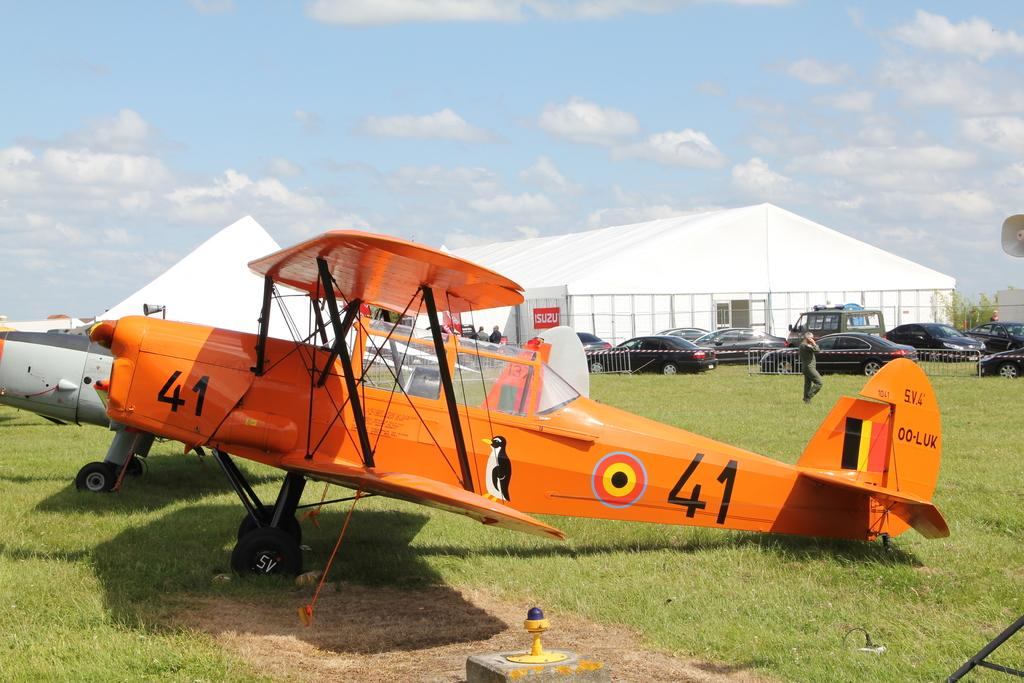Provide a one-sentence caption for the provided image. An orange plane on the ground labeled 41. 